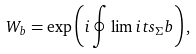<formula> <loc_0><loc_0><loc_500><loc_500>W _ { b } = \exp \left ( { i \oint \lim i t s _ { \Sigma } b } \right ) ,</formula> 